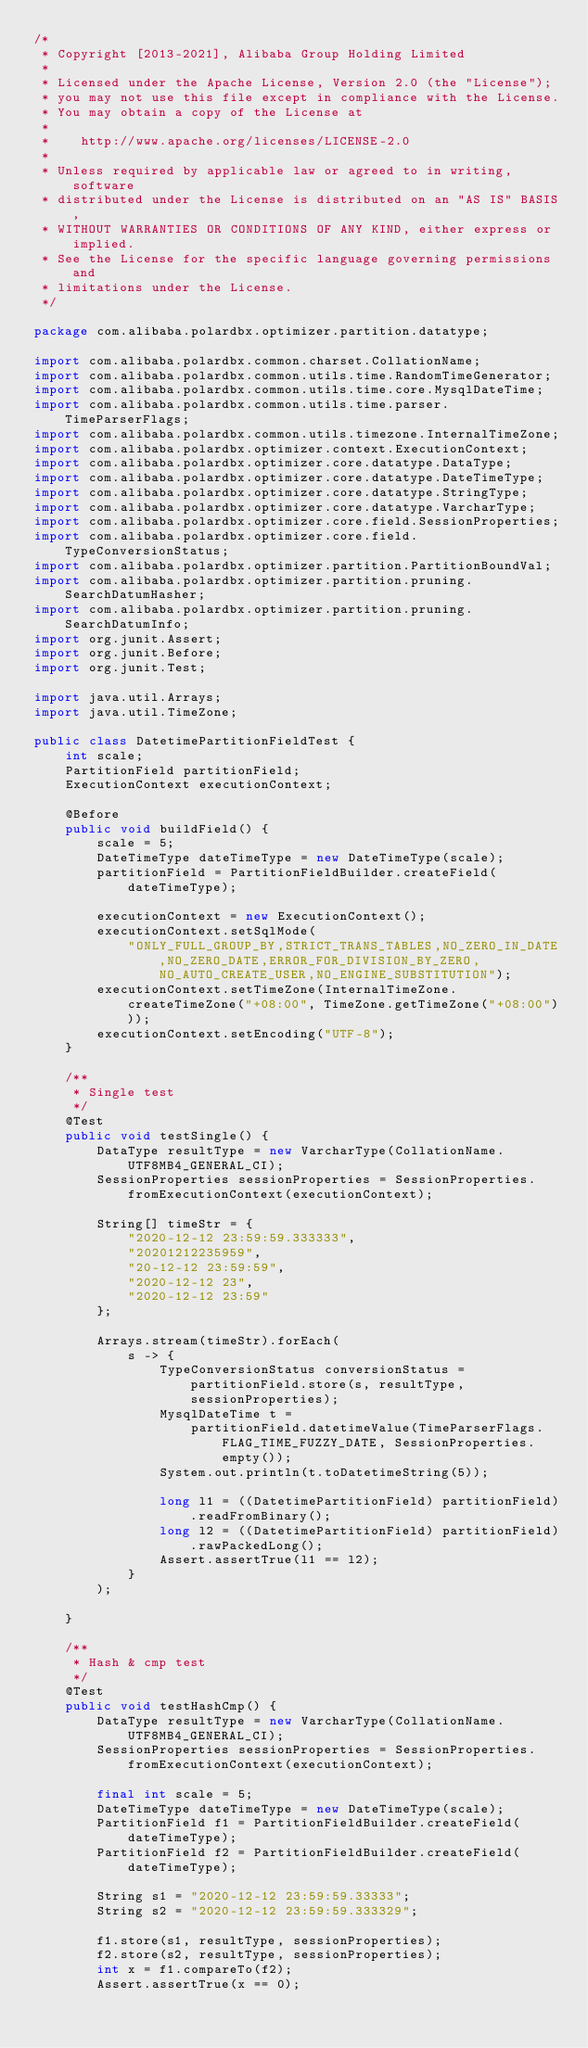<code> <loc_0><loc_0><loc_500><loc_500><_Java_>/*
 * Copyright [2013-2021], Alibaba Group Holding Limited
 *
 * Licensed under the Apache License, Version 2.0 (the "License");
 * you may not use this file except in compliance with the License.
 * You may obtain a copy of the License at
 *
 *    http://www.apache.org/licenses/LICENSE-2.0
 *
 * Unless required by applicable law or agreed to in writing, software
 * distributed under the License is distributed on an "AS IS" BASIS,
 * WITHOUT WARRANTIES OR CONDITIONS OF ANY KIND, either express or implied.
 * See the License for the specific language governing permissions and
 * limitations under the License.
 */

package com.alibaba.polardbx.optimizer.partition.datatype;

import com.alibaba.polardbx.common.charset.CollationName;
import com.alibaba.polardbx.common.utils.time.RandomTimeGenerator;
import com.alibaba.polardbx.common.utils.time.core.MysqlDateTime;
import com.alibaba.polardbx.common.utils.time.parser.TimeParserFlags;
import com.alibaba.polardbx.common.utils.timezone.InternalTimeZone;
import com.alibaba.polardbx.optimizer.context.ExecutionContext;
import com.alibaba.polardbx.optimizer.core.datatype.DataType;
import com.alibaba.polardbx.optimizer.core.datatype.DateTimeType;
import com.alibaba.polardbx.optimizer.core.datatype.StringType;
import com.alibaba.polardbx.optimizer.core.datatype.VarcharType;
import com.alibaba.polardbx.optimizer.core.field.SessionProperties;
import com.alibaba.polardbx.optimizer.core.field.TypeConversionStatus;
import com.alibaba.polardbx.optimizer.partition.PartitionBoundVal;
import com.alibaba.polardbx.optimizer.partition.pruning.SearchDatumHasher;
import com.alibaba.polardbx.optimizer.partition.pruning.SearchDatumInfo;
import org.junit.Assert;
import org.junit.Before;
import org.junit.Test;

import java.util.Arrays;
import java.util.TimeZone;

public class DatetimePartitionFieldTest {
    int scale;
    PartitionField partitionField;
    ExecutionContext executionContext;

    @Before
    public void buildField() {
        scale = 5;
        DateTimeType dateTimeType = new DateTimeType(scale);
        partitionField = PartitionFieldBuilder.createField(dateTimeType);

        executionContext = new ExecutionContext();
        executionContext.setSqlMode(
            "ONLY_FULL_GROUP_BY,STRICT_TRANS_TABLES,NO_ZERO_IN_DATE,NO_ZERO_DATE,ERROR_FOR_DIVISION_BY_ZERO,NO_AUTO_CREATE_USER,NO_ENGINE_SUBSTITUTION");
        executionContext.setTimeZone(InternalTimeZone.createTimeZone("+08:00", TimeZone.getTimeZone("+08:00")));
        executionContext.setEncoding("UTF-8");
    }

    /**
     * Single test
     */
    @Test
    public void testSingle() {
        DataType resultType = new VarcharType(CollationName.UTF8MB4_GENERAL_CI);
        SessionProperties sessionProperties = SessionProperties.fromExecutionContext(executionContext);

        String[] timeStr = {
            "2020-12-12 23:59:59.333333",
            "20201212235959",
            "20-12-12 23:59:59",
            "2020-12-12 23",
            "2020-12-12 23:59"
        };

        Arrays.stream(timeStr).forEach(
            s -> {
                TypeConversionStatus conversionStatus = partitionField.store(s, resultType, sessionProperties);
                MysqlDateTime t =
                    partitionField.datetimeValue(TimeParserFlags.FLAG_TIME_FUZZY_DATE, SessionProperties.empty());
                System.out.println(t.toDatetimeString(5));

                long l1 = ((DatetimePartitionField) partitionField).readFromBinary();
                long l2 = ((DatetimePartitionField) partitionField).rawPackedLong();
                Assert.assertTrue(l1 == l2);
            }
        );

    }

    /**
     * Hash & cmp test
     */
    @Test
    public void testHashCmp() {
        DataType resultType = new VarcharType(CollationName.UTF8MB4_GENERAL_CI);
        SessionProperties sessionProperties = SessionProperties.fromExecutionContext(executionContext);

        final int scale = 5;
        DateTimeType dateTimeType = new DateTimeType(scale);
        PartitionField f1 = PartitionFieldBuilder.createField(dateTimeType);
        PartitionField f2 = PartitionFieldBuilder.createField(dateTimeType);

        String s1 = "2020-12-12 23:59:59.33333";
        String s2 = "2020-12-12 23:59:59.333329";

        f1.store(s1, resultType, sessionProperties);
        f2.store(s2, resultType, sessionProperties);
        int x = f1.compareTo(f2);
        Assert.assertTrue(x == 0);
</code> 